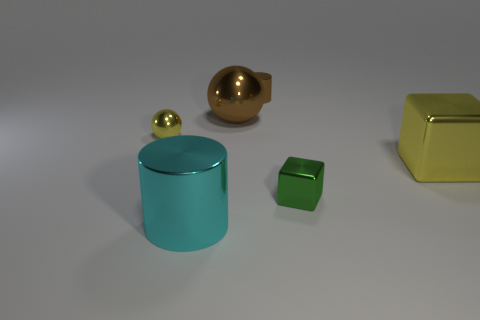Is the number of tiny spheres that are on the right side of the big yellow metal block less than the number of cubes?
Provide a short and direct response. Yes. Do the small brown metallic thing and the big brown thing have the same shape?
Ensure brevity in your answer.  No. What size is the brown cylinder that is made of the same material as the tiny yellow thing?
Make the answer very short. Small. Are there fewer gray metal cubes than brown spheres?
Provide a succinct answer. Yes. How many large things are either yellow metallic objects or yellow metal cubes?
Make the answer very short. 1. What number of shiny objects are on the right side of the large cyan metallic cylinder and in front of the tiny brown shiny object?
Offer a terse response. 3. Are there more large cyan metallic things than objects?
Provide a short and direct response. No. How many other things are there of the same shape as the small green metallic thing?
Keep it short and to the point. 1. Do the large cube and the small metal block have the same color?
Make the answer very short. No. What material is the small object that is right of the large brown ball and behind the green object?
Your answer should be compact. Metal. 